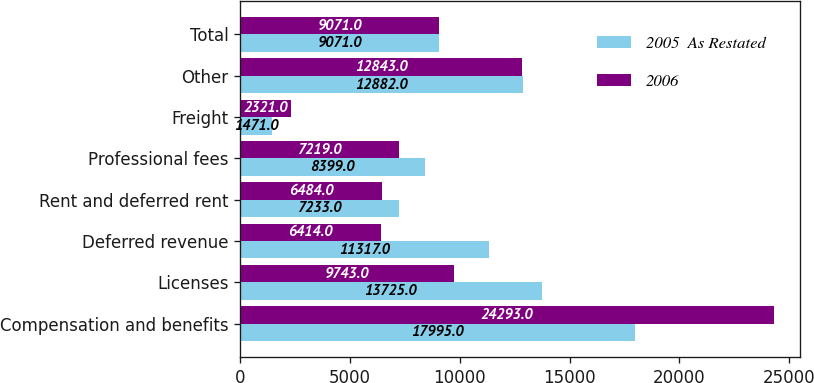Convert chart to OTSL. <chart><loc_0><loc_0><loc_500><loc_500><stacked_bar_chart><ecel><fcel>Compensation and benefits<fcel>Licenses<fcel>Deferred revenue<fcel>Rent and deferred rent<fcel>Professional fees<fcel>Freight<fcel>Other<fcel>Total<nl><fcel>2005  As Restated<fcel>17995<fcel>13725<fcel>11317<fcel>7233<fcel>8399<fcel>1471<fcel>12882<fcel>9071<nl><fcel>2006<fcel>24293<fcel>9743<fcel>6414<fcel>6484<fcel>7219<fcel>2321<fcel>12843<fcel>9071<nl></chart> 